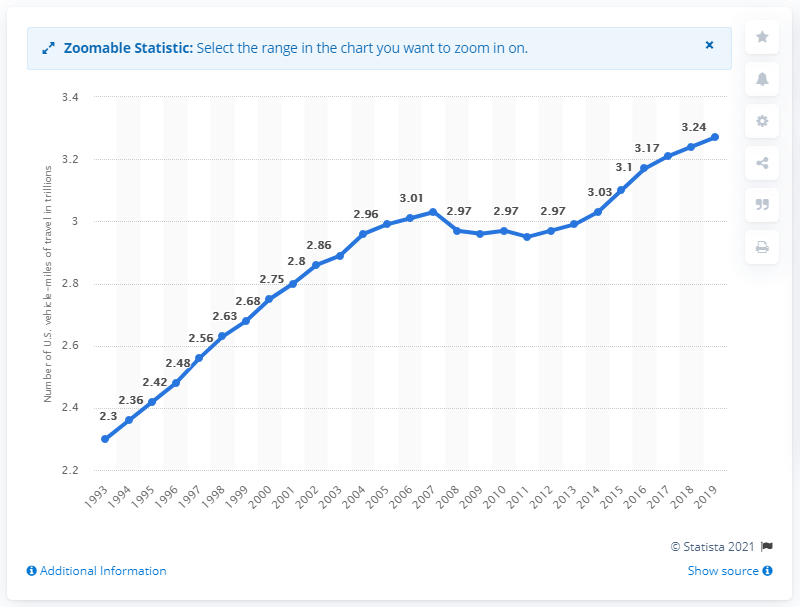Mention a couple of crucial points in this snapshot. In 2019, the total number of vehicle-miles traveled on all roads in the United States was 3.27 trillion miles. 